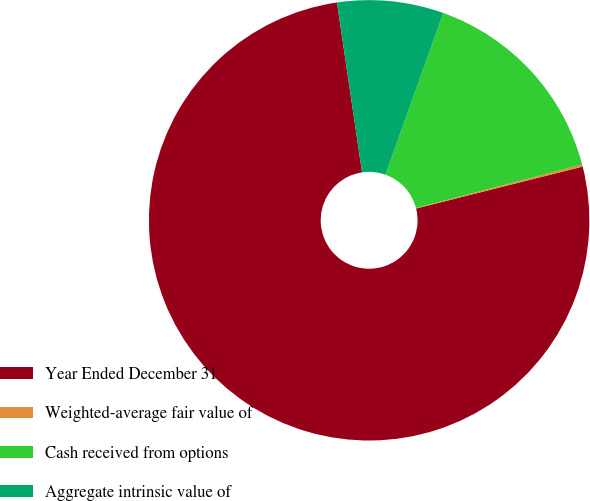Convert chart to OTSL. <chart><loc_0><loc_0><loc_500><loc_500><pie_chart><fcel>Year Ended December 31<fcel>Weighted-average fair value of<fcel>Cash received from options<fcel>Aggregate intrinsic value of<nl><fcel>76.59%<fcel>0.16%<fcel>15.45%<fcel>7.8%<nl></chart> 